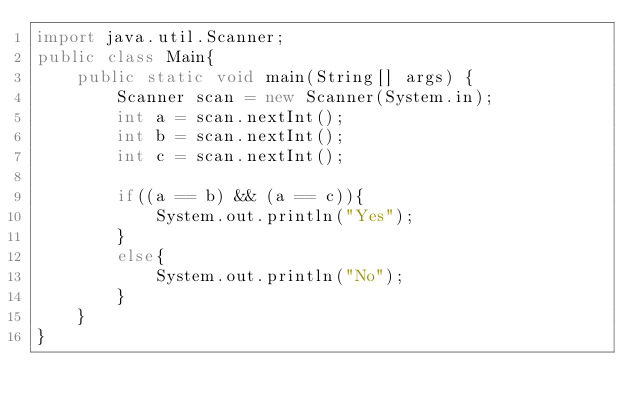<code> <loc_0><loc_0><loc_500><loc_500><_Java_>import java.util.Scanner;
public class Main{
    public static void main(String[] args) {
        Scanner scan = new Scanner(System.in);
        int a = scan.nextInt();
        int b = scan.nextInt();
        int c = scan.nextInt();

        if((a == b) && (a == c)){            
            System.out.println("Yes");
        }
        else{
            System.out.println("No");
        }
    }
}
</code> 